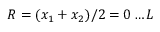<formula> <loc_0><loc_0><loc_500><loc_500>R = ( x _ { 1 } + x _ { 2 } ) / 2 = 0 \dots L</formula> 